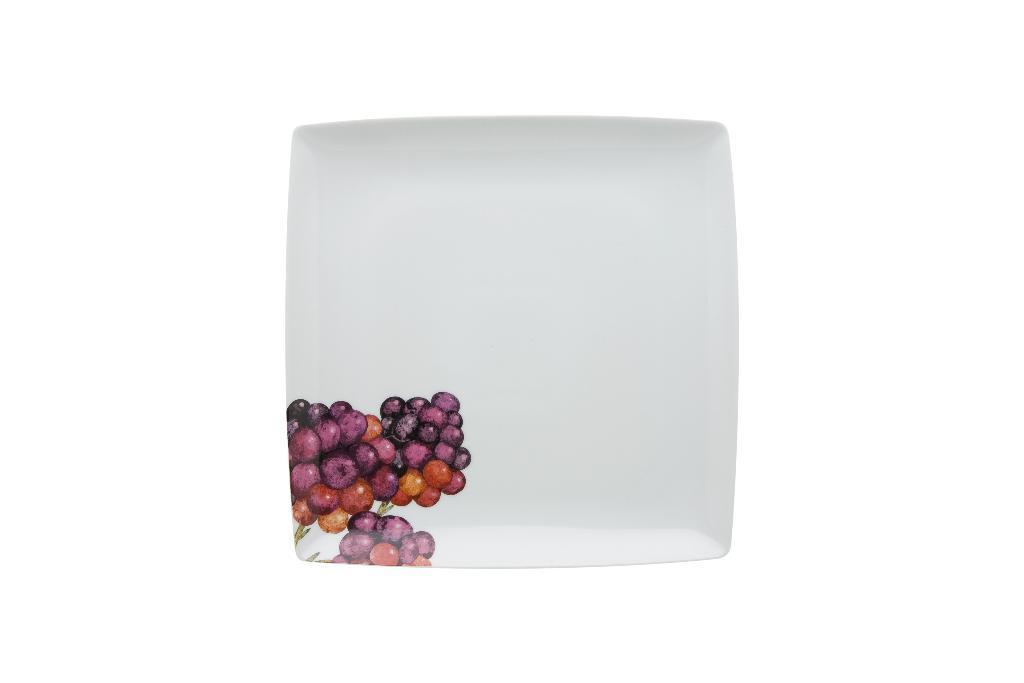In one or two sentences, can you explain what this image depicts? In this image we can see a plate on which grapes design is printed. 